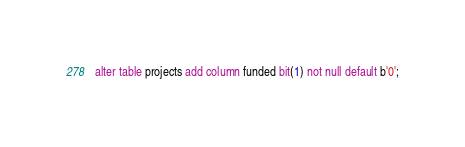Convert code to text. <code><loc_0><loc_0><loc_500><loc_500><_SQL_>alter table projects add column funded bit(1) not null default b'0';</code> 